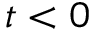Convert formula to latex. <formula><loc_0><loc_0><loc_500><loc_500>t < 0</formula> 